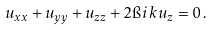<formula> <loc_0><loc_0><loc_500><loc_500>u _ { x x } + u _ { y y } + u _ { z z } + 2 \i i \, k u _ { z } = 0 \, .</formula> 